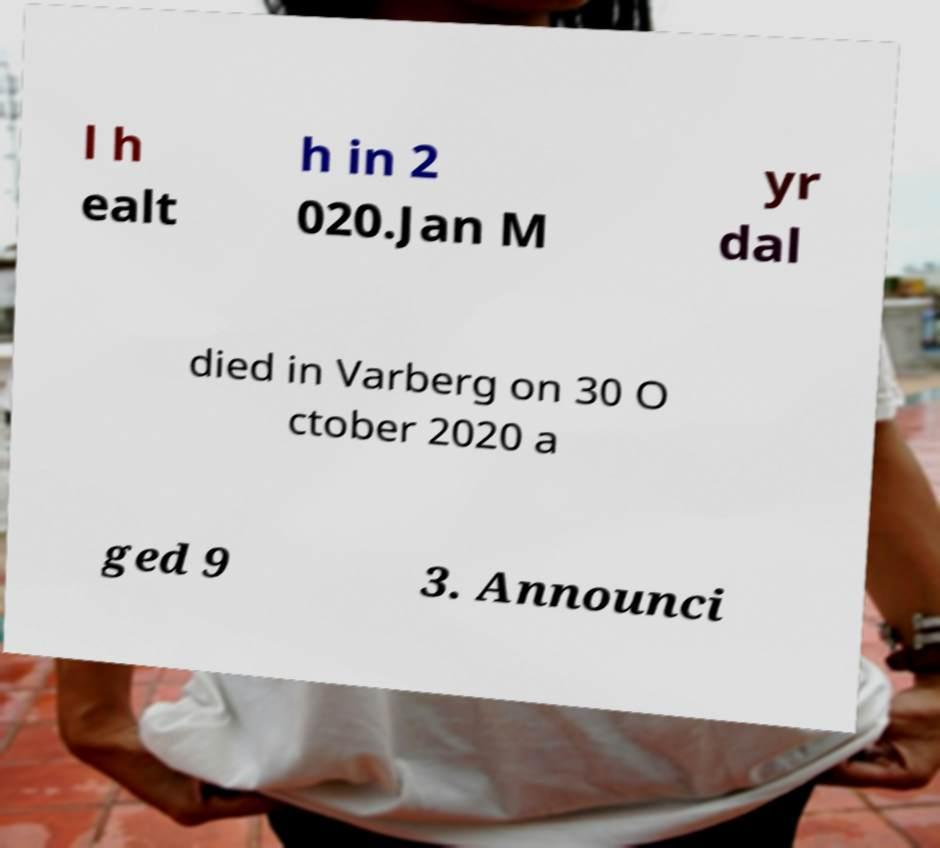Can you accurately transcribe the text from the provided image for me? l h ealt h in 2 020.Jan M yr dal died in Varberg on 30 O ctober 2020 a ged 9 3. Announci 